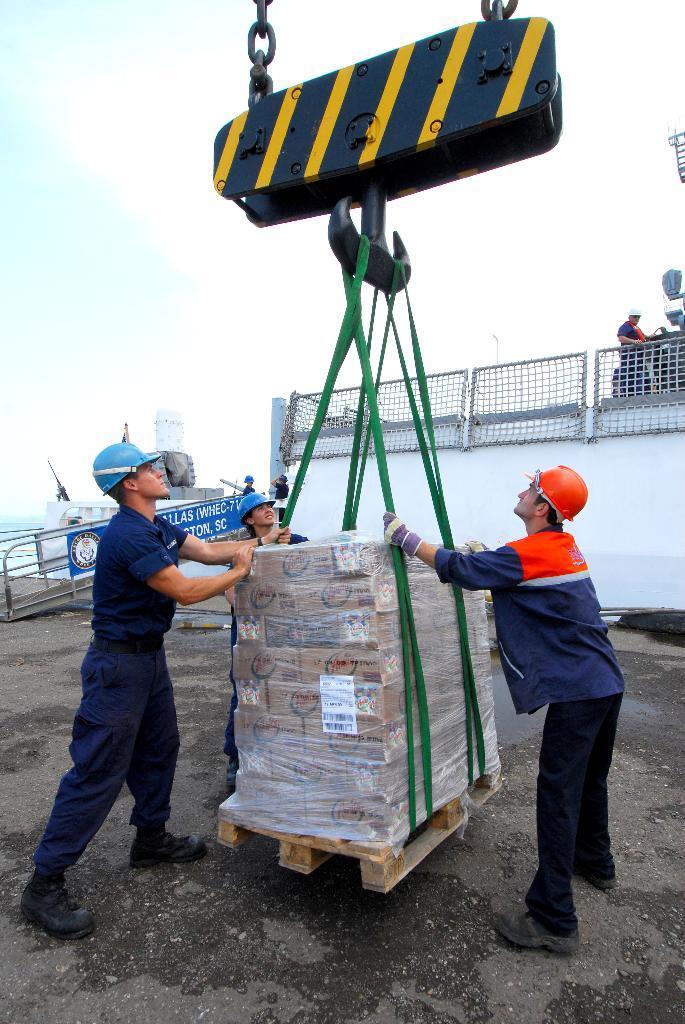Could you give a brief overview of what you see in this image? In this image in the center there are persons standing and holding an object which is brown in colour and green in colour. In the background there is a board with some text written on it and there are persons, there is a wall and there is a fence and behind the fence there is a person standing and the sky is cloudy and there is water. 